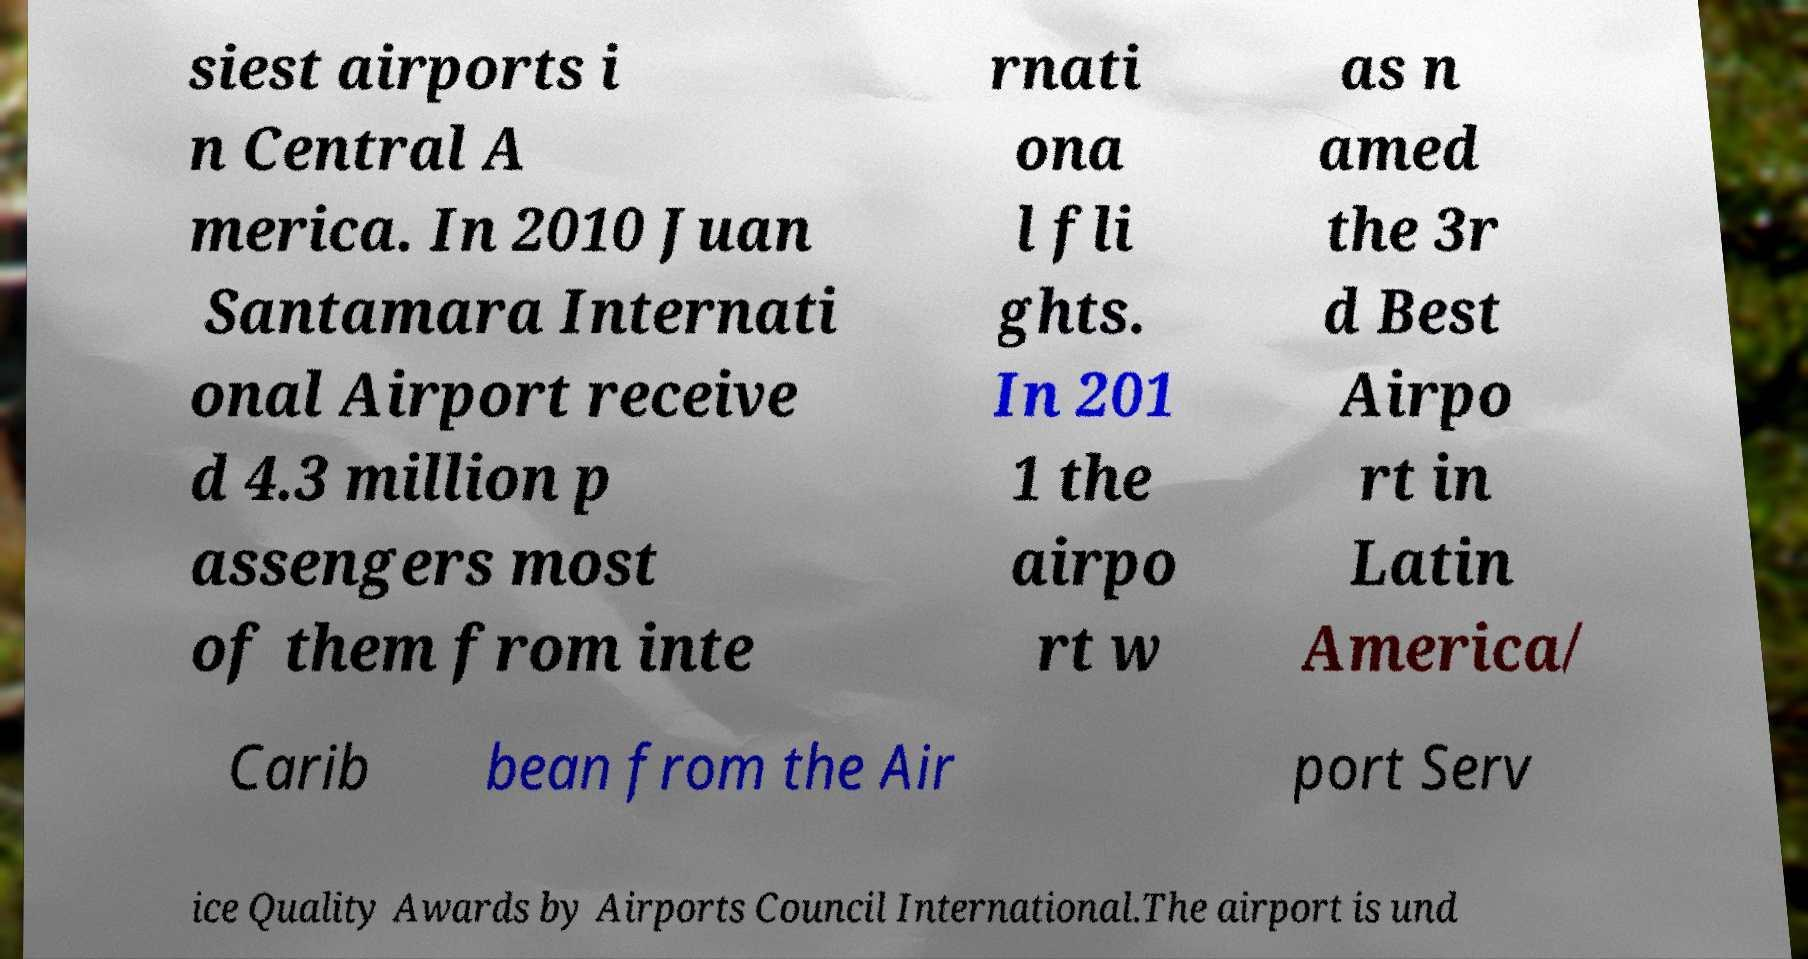Please read and relay the text visible in this image. What does it say? siest airports i n Central A merica. In 2010 Juan Santamara Internati onal Airport receive d 4.3 million p assengers most of them from inte rnati ona l fli ghts. In 201 1 the airpo rt w as n amed the 3r d Best Airpo rt in Latin America/ Carib bean from the Air port Serv ice Quality Awards by Airports Council International.The airport is und 